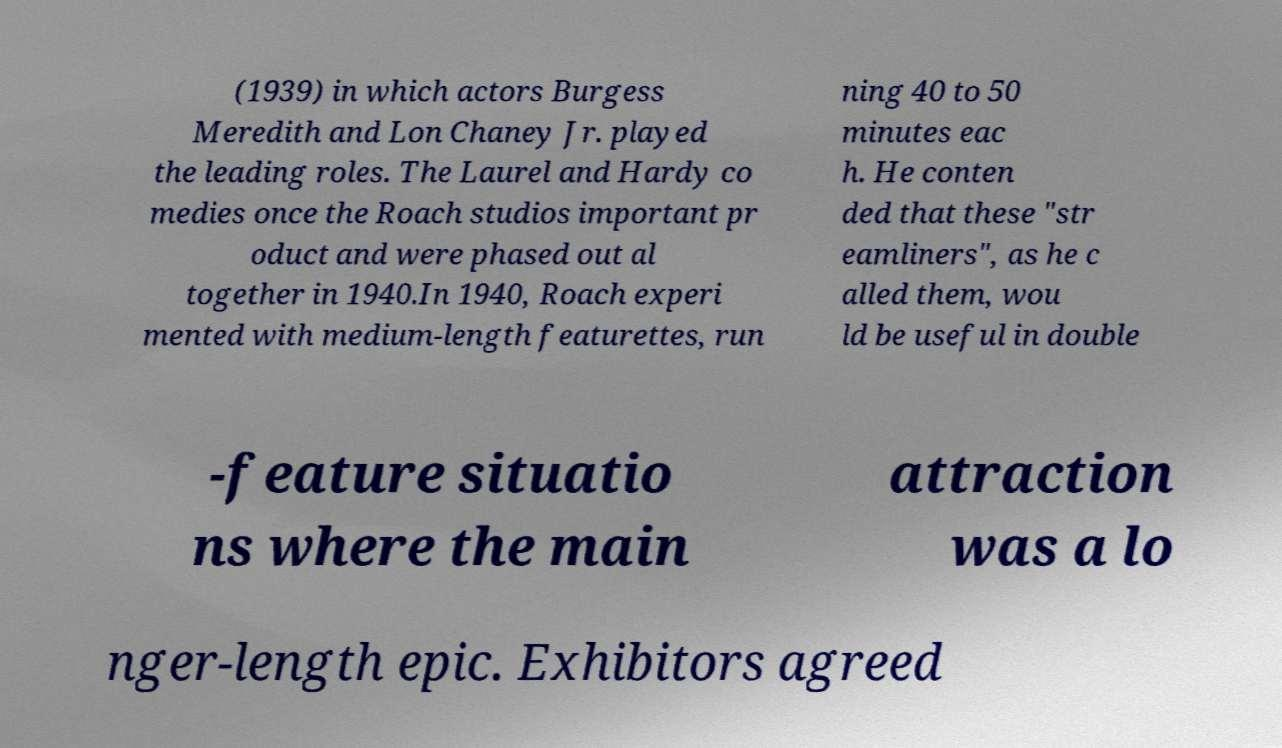For documentation purposes, I need the text within this image transcribed. Could you provide that? (1939) in which actors Burgess Meredith and Lon Chaney Jr. played the leading roles. The Laurel and Hardy co medies once the Roach studios important pr oduct and were phased out al together in 1940.In 1940, Roach experi mented with medium-length featurettes, run ning 40 to 50 minutes eac h. He conten ded that these "str eamliners", as he c alled them, wou ld be useful in double -feature situatio ns where the main attraction was a lo nger-length epic. Exhibitors agreed 